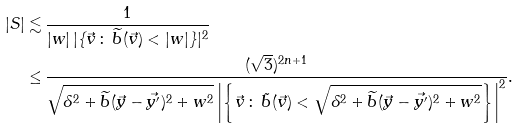<formula> <loc_0><loc_0><loc_500><loc_500>| S | \lesssim & \, \frac { 1 } { | w | \, | \{ \vec { v } \, \colon \, \widetilde { b } ( \vec { v } ) < | w | \} | ^ { 2 } } \\ \leq & \, \frac { ( \sqrt { 3 } ) ^ { 2 n + 1 } } { \sqrt { \delta ^ { 2 } + \widetilde { b } ( \vec { y } - \vec { y ^ { \prime } } ) ^ { 2 } + w ^ { 2 } } \left | \left \{ \vec { v } \, \colon \, \tilde { b } ( \vec { v } ) < \sqrt { \delta ^ { 2 } + \widetilde { b } ( \vec { y } - \vec { y ^ { \prime } } ) ^ { 2 } + w ^ { 2 } } \right \} \right | ^ { 2 } } . \\</formula> 